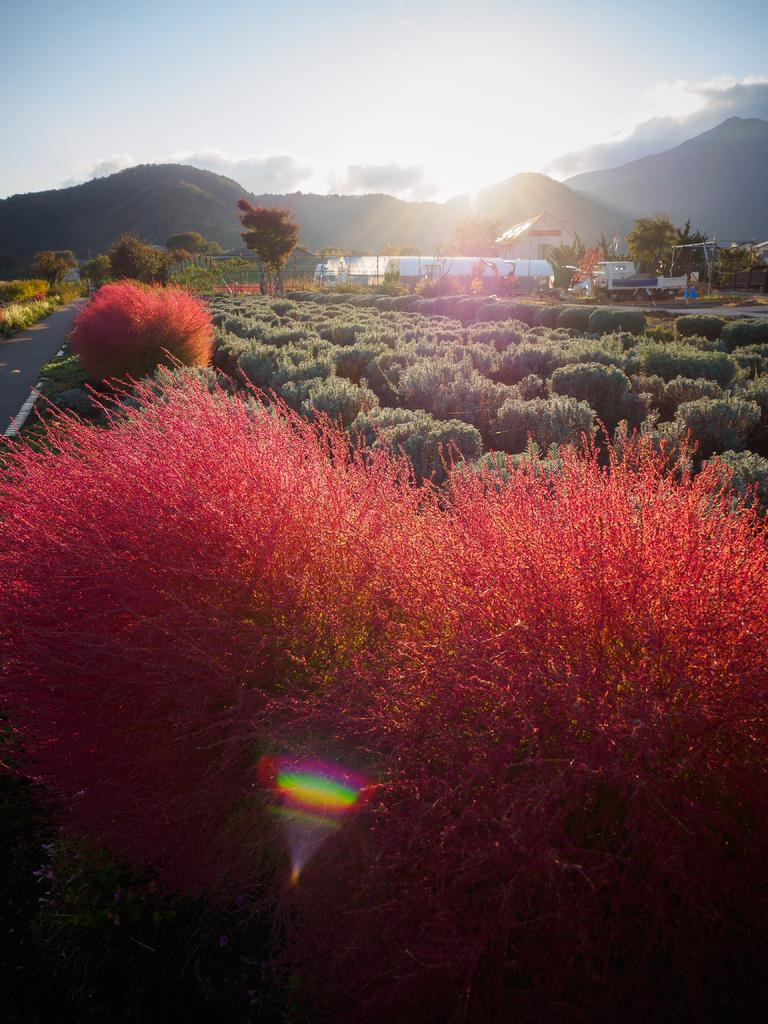Where was the image taken? The image was taken outside. What type of vegetation can be seen in the image? There are bushes and trees in the image. What geographical feature is visible at the top of the image? There are mountains at the top of the image. What part of the natural environment is visible in the image? The sky is visible at the top of the image. What type of wax can be seen dripping from the hands in the image? There are no hands or wax present in the image. 